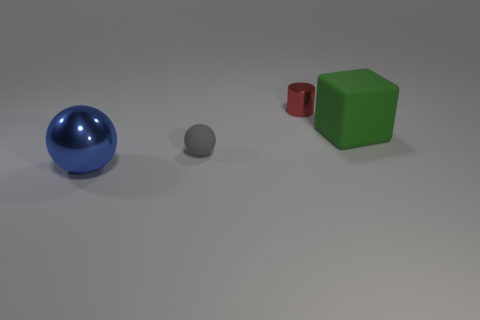Add 3 tiny spheres. How many objects exist? 7 Add 4 red metallic cylinders. How many red metallic cylinders exist? 5 Subtract 1 gray spheres. How many objects are left? 3 Subtract all cyan cylinders. Subtract all shiny things. How many objects are left? 2 Add 1 tiny gray rubber objects. How many tiny gray rubber objects are left? 2 